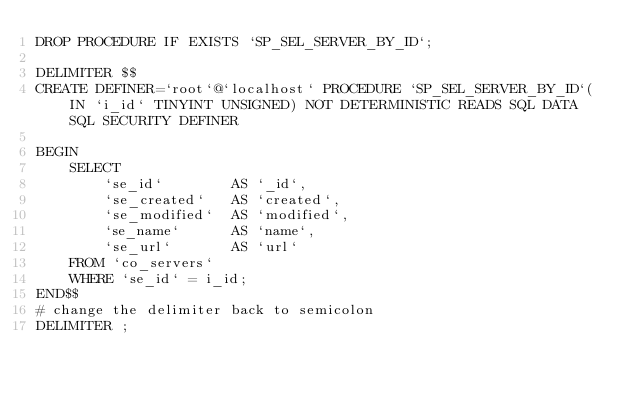<code> <loc_0><loc_0><loc_500><loc_500><_SQL_>DROP PROCEDURE IF EXISTS `SP_SEL_SERVER_BY_ID`;

DELIMITER $$
CREATE DEFINER=`root`@`localhost` PROCEDURE `SP_SEL_SERVER_BY_ID`(IN `i_id`	TINYINT UNSIGNED) NOT DETERMINISTIC READS SQL DATA SQL SECURITY DEFINER

BEGIN 
	SELECT
		`se_id`        AS `_id`,
	  	`se_created`   AS `created`,
	  	`se_modified`  AS `modified`,
	  	`se_name`      AS `name`,
		`se_url`       AS `url`
	FROM `co_servers`
	WHERE `se_id` = i_id;
END$$
# change the delimiter back to semicolon
DELIMITER ;</code> 